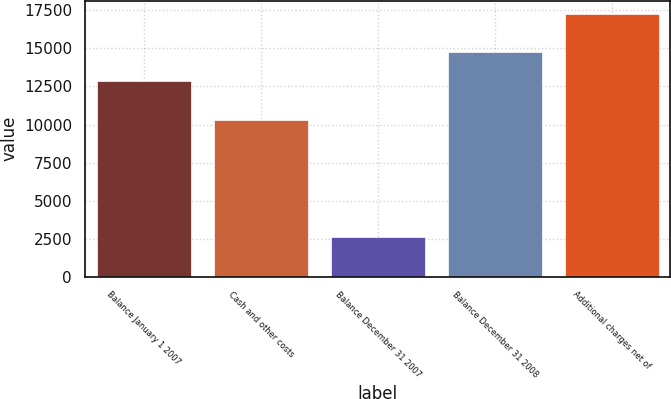Convert chart. <chart><loc_0><loc_0><loc_500><loc_500><bar_chart><fcel>Balance January 1 2007<fcel>Cash and other costs<fcel>Balance December 31 2007<fcel>Balance December 31 2008<fcel>Additional charges net of<nl><fcel>12861<fcel>10273<fcel>2588<fcel>14755<fcel>17263<nl></chart> 